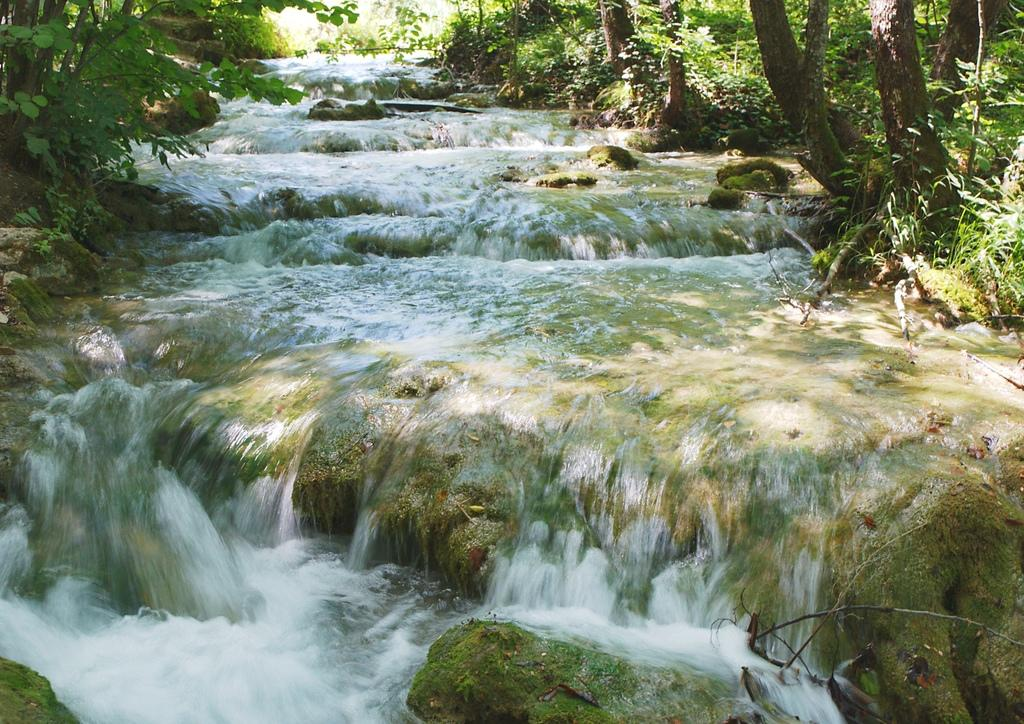What type of vegetation can be seen in the image? There are trees in the image. What is happening with the water in the image? Water is flowing on stones in the image. Where is the aunt sitting in the image? There is no aunt present in the image. What wish can be granted by looking at the image? There is no wish-granting element in the image. 